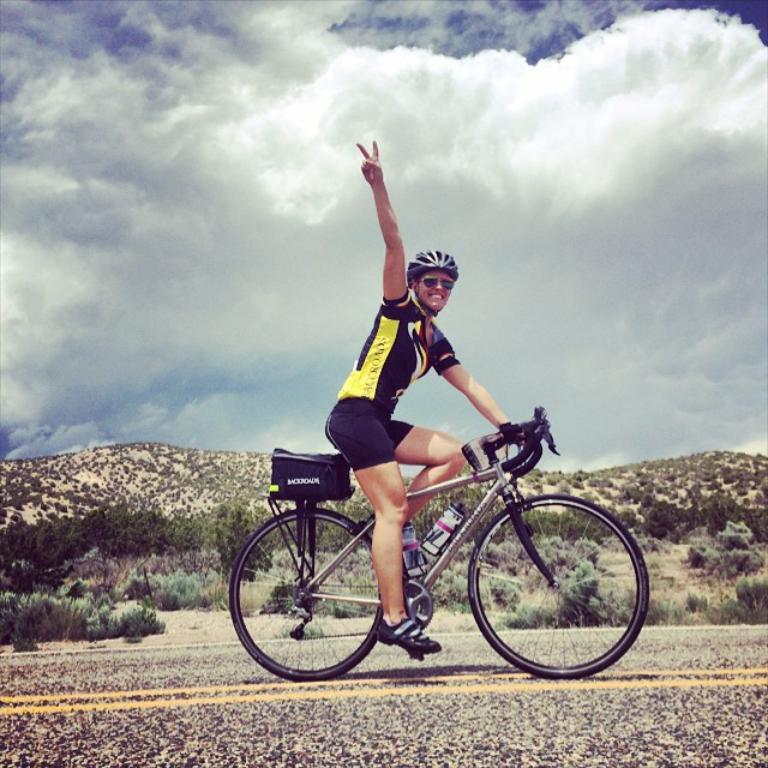What is the main subject of the image? There is a person in the image. What is the person doing in the image? The person is riding a bicycle and waving their hand. What can be seen in the background of the image? There are trees visible in the image. How would you describe the weather in the image? The sky is cloudy in the image. How many boys are ironing their clothes in the image? There are no boys ironing their clothes in the image; it features a person riding a bicycle and waving their hand. What type of fabric is being rubbed on the person's back in the image? There is no fabric being rubbed on anyone's back in the image. 